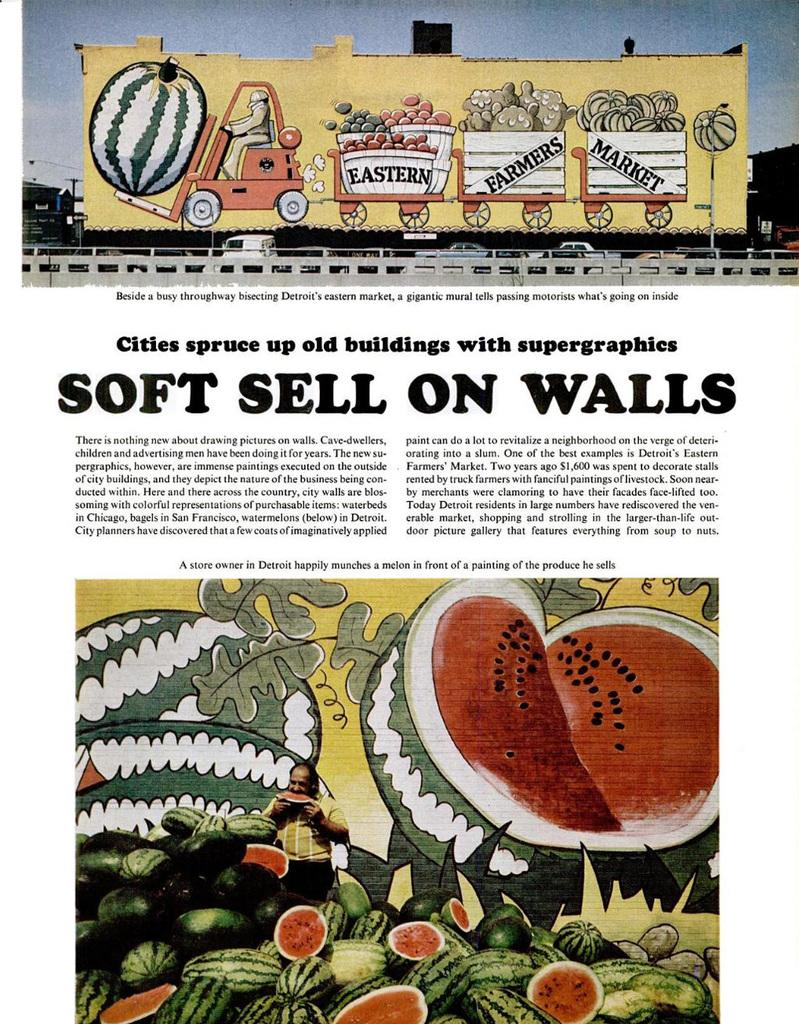What is the main subject of the image? The main subject of the image is a picture. What is depicted in the picture? The picture contains a watermelon. What phrase is printed on a wall in the image? The phrase "SOFT SHELLS ON WALLS" is printed on a wall in the image. What type of bone can be seen playing a musical instrument on the stage in the image? There is no stage, bone, or musical instrument present in the image. 